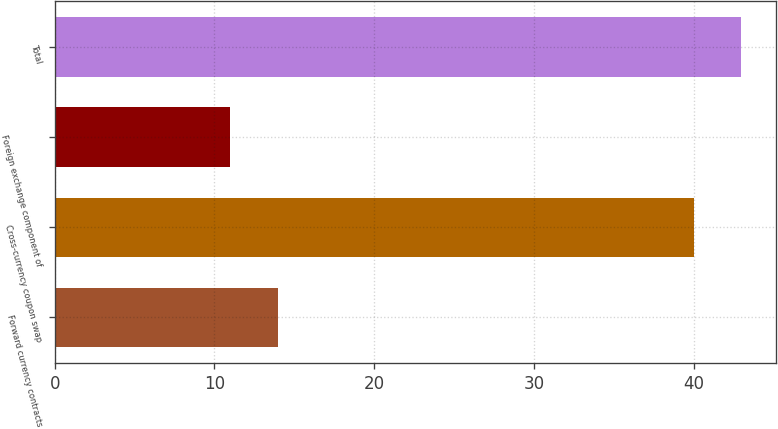<chart> <loc_0><loc_0><loc_500><loc_500><bar_chart><fcel>Forward currency contracts<fcel>Cross-currency coupon swap<fcel>Foreign exchange component of<fcel>Total<nl><fcel>14<fcel>40<fcel>11<fcel>43<nl></chart> 